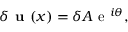Convert formula to latex. <formula><loc_0><loc_0><loc_500><loc_500>\delta u ( x ) = \delta A e ^ { i \theta } ,</formula> 